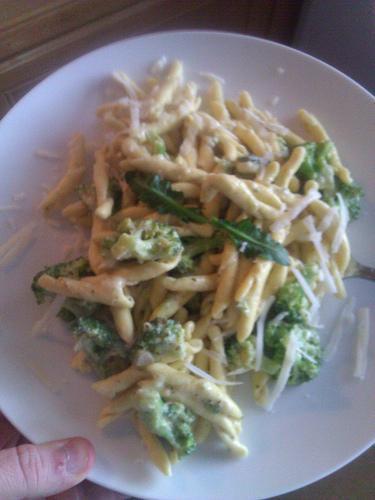How many plates are there?
Give a very brief answer. 1. 